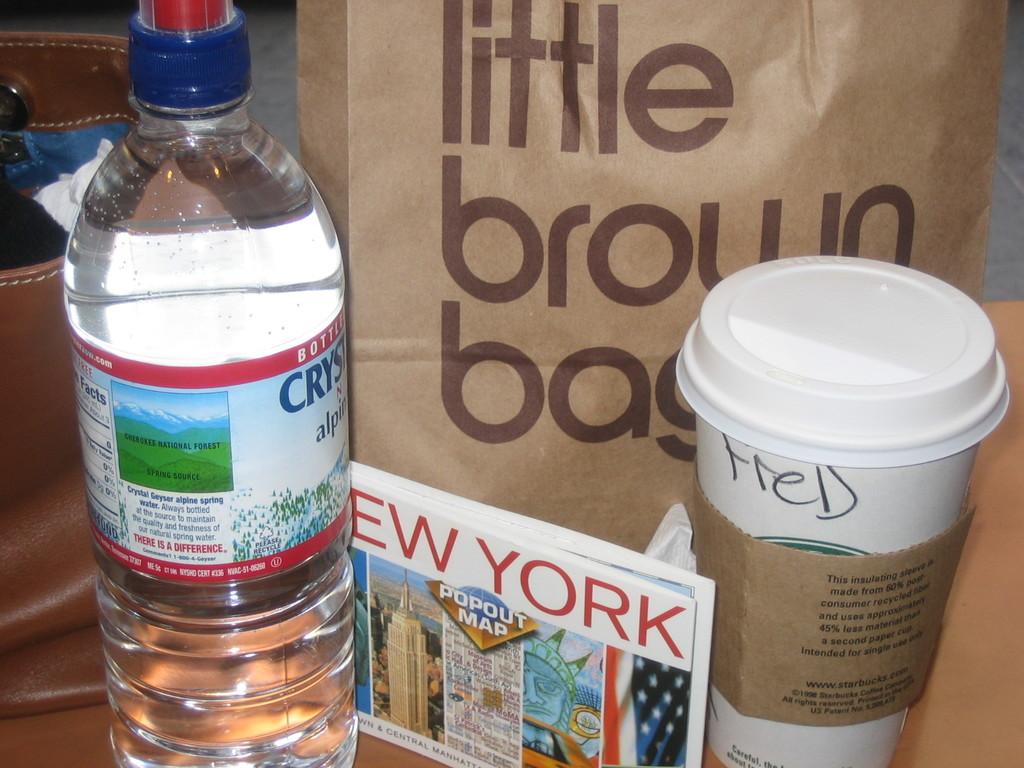What's the name of the coffee drinker?
Provide a short and direct response. Fred. What size brown bag is this?
Keep it short and to the point. Little. 